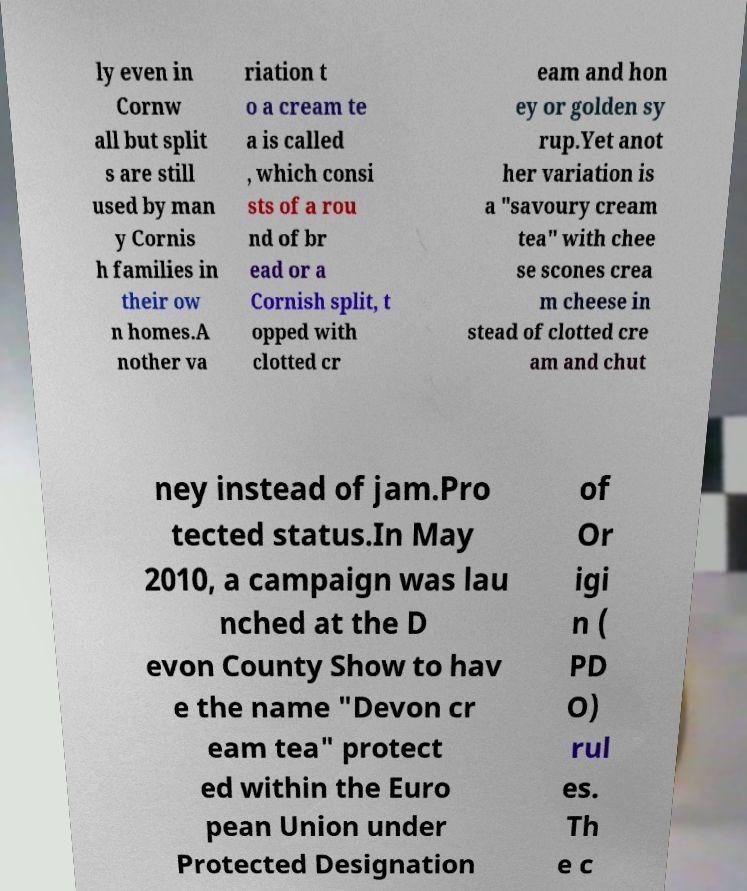Can you accurately transcribe the text from the provided image for me? ly even in Cornw all but split s are still used by man y Cornis h families in their ow n homes.A nother va riation t o a cream te a is called , which consi sts of a rou nd of br ead or a Cornish split, t opped with clotted cr eam and hon ey or golden sy rup.Yet anot her variation is a "savoury cream tea" with chee se scones crea m cheese in stead of clotted cre am and chut ney instead of jam.Pro tected status.In May 2010, a campaign was lau nched at the D evon County Show to hav e the name "Devon cr eam tea" protect ed within the Euro pean Union under Protected Designation of Or igi n ( PD O) rul es. Th e c 